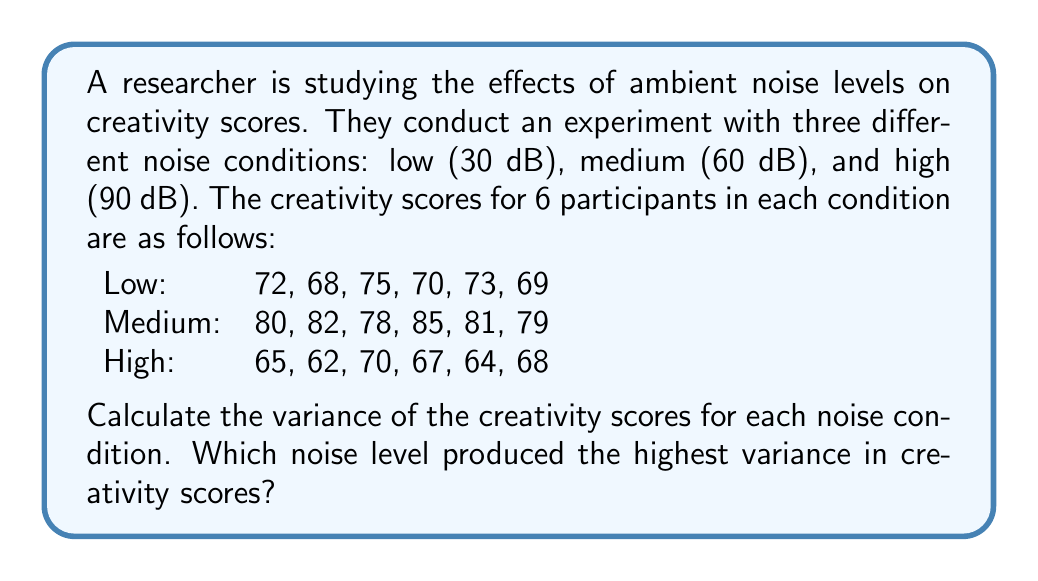Can you solve this math problem? To solve this problem, we need to calculate the variance for each noise condition. The formula for variance is:

$$ \text{Variance} = s^2 = \frac{\sum_{i=1}^{n} (x_i - \bar{x})^2}{n - 1} $$

Where $x_i$ are the individual scores, $\bar{x}$ is the mean, and $n$ is the number of scores.

Let's calculate for each condition:

1. Low noise condition:

First, calculate the mean:
$\bar{x}_{\text{low}} = \frac{72 + 68 + 75 + 70 + 73 + 69}{6} = 71.1667$

Now, calculate the squared differences from the mean:
$(72 - 71.1667)^2 = 0.6944$
$(68 - 71.1667)^2 = 10.0278$
$(75 - 71.1667)^2 = 14.6944$
$(70 - 71.1667)^2 = 1.3611$
$(73 - 71.1667)^2 = 3.3611$
$(69 - 71.1667)^2 = 4.6944$

Sum these differences:
$0.6944 + 10.0278 + 14.6944 + 1.3611 + 3.3611 + 4.6944 = 34.8332$

Calculate the variance:
$s^2_{\text{low}} = \frac{34.8332}{6 - 1} = 6.9666$

2. Medium noise condition:

Mean: $\bar{x}_{\text{medium}} = \frac{80 + 82 + 78 + 85 + 81 + 79}{6} = 80.8333$

Squared differences: $(80 - 80.8333)^2 = 0.6944$, $(82 - 80.8333)^2 = 1.3611$, $(78 - 80.8333)^2 = 8.0278$, $(85 - 80.8333)^2 = 17.3611$, $(81 - 80.8333)^2 = 0.0278$, $(79 - 80.8333)^2 = 3.3611$

Sum of squared differences: $30.8333$

Variance: $s^2_{\text{medium}} = \frac{30.8333}{6 - 1} = 6.1667$

3. High noise condition:

Mean: $\bar{x}_{\text{high}} = \frac{65 + 62 + 70 + 67 + 64 + 68}{6} = 66$

Squared differences: $(65 - 66)^2 = 1$, $(62 - 66)^2 = 16$, $(70 - 66)^2 = 16$, $(67 - 66)^2 = 1$, $(64 - 66)^2 = 4$, $(68 - 66)^2 = 4$

Sum of squared differences: $42$

Variance: $s^2_{\text{high}} = \frac{42}{6 - 1} = 8.4$
Answer: The variances for each noise condition are:
Low noise: $6.9666$
Medium noise: $6.1667$
High noise: $8.4$

The high noise condition (90 dB) produced the highest variance in creativity scores. 